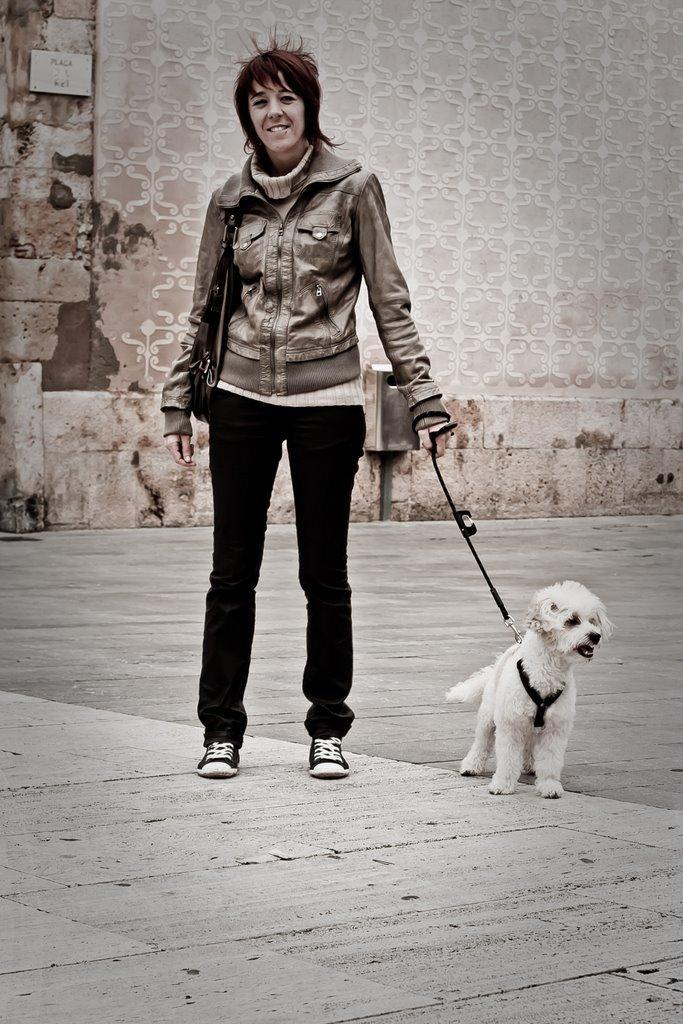What is happening in the image? There is a person in the image holding a dog. Can you describe the background of the image? There is a wall with a design in the background of the image. What type of apple is the person eating in the image? There is no apple present in the image; the person is holding a dog. 